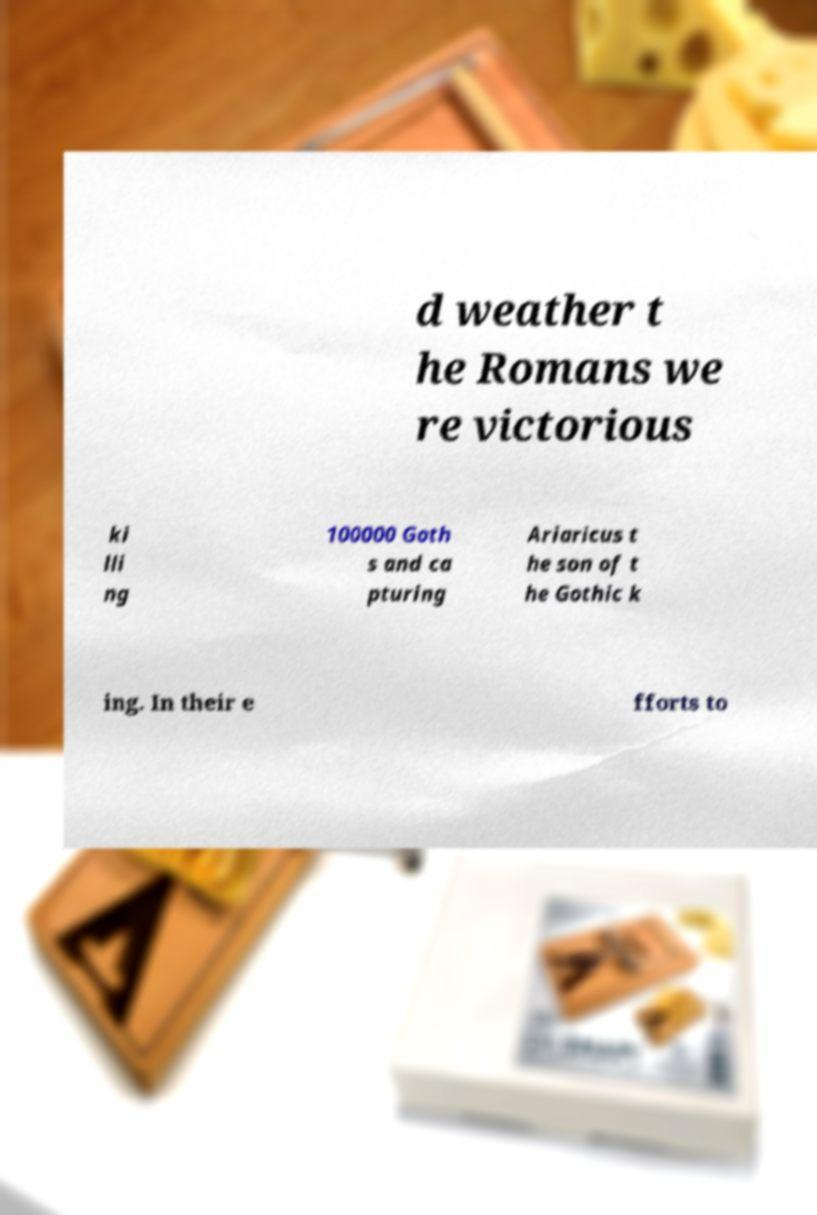Can you read and provide the text displayed in the image?This photo seems to have some interesting text. Can you extract and type it out for me? d weather t he Romans we re victorious ki lli ng 100000 Goth s and ca pturing Ariaricus t he son of t he Gothic k ing. In their e fforts to 